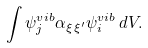<formula> <loc_0><loc_0><loc_500><loc_500>\int \psi _ { j } ^ { v i b } \alpha _ { \xi \, \xi ^ { \prime } } \psi _ { i } ^ { v i b } \, d V .</formula> 